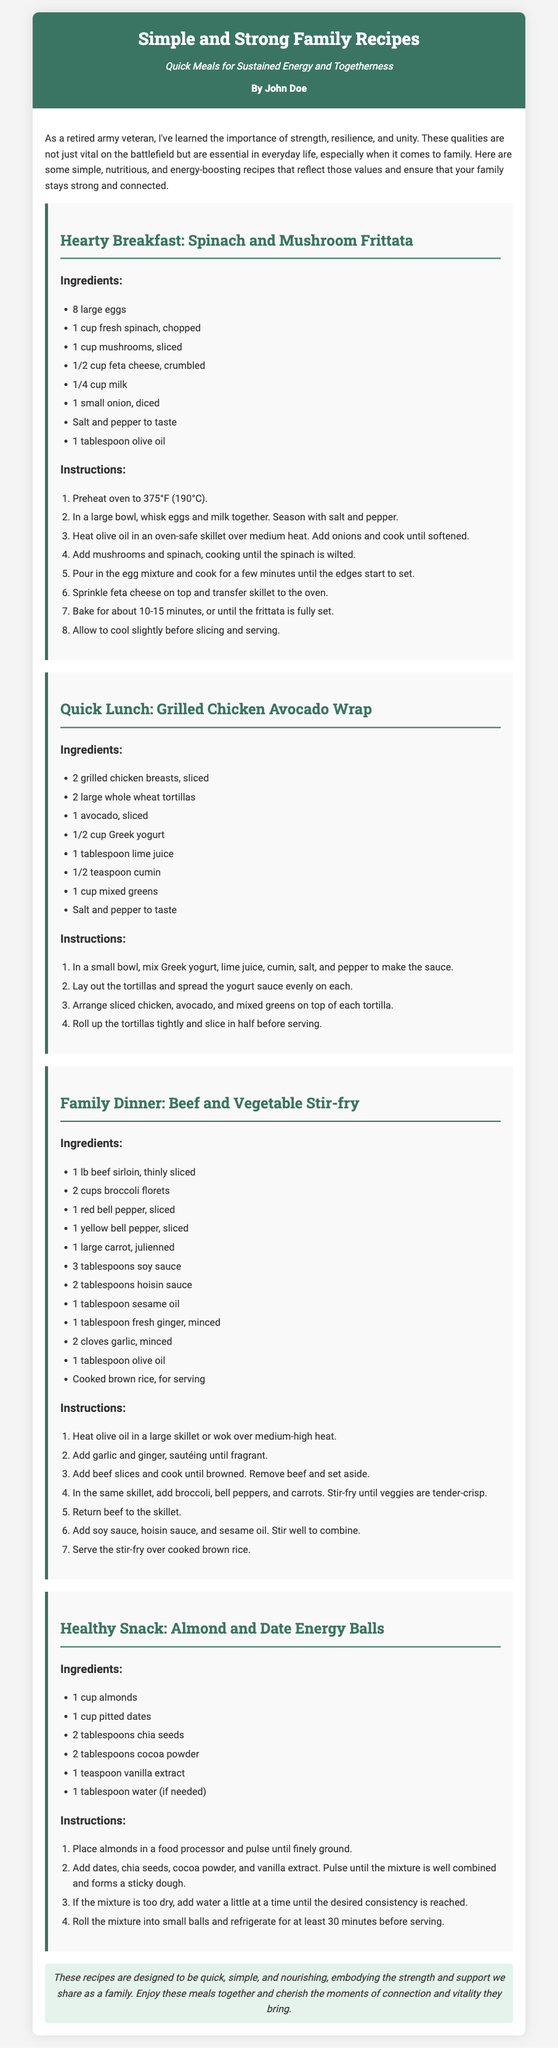What is the title of the document? The title is found at the top of the header section of the document.
Answer: Simple and Strong Family Recipes Who is the author of the recipes? The author is indicated in the header section.
Answer: John Doe What is the main ingredient in the Spinach and Mushroom Frittata? The recipe lists ingredients, and spinach is highlighted in the frittata section.
Answer: Spinach How many eggs are used in the frittata recipe? The ingredients for the frittata include a specific quantity of eggs.
Answer: 8 large eggs What is one of the sauces used in the Grilled Chicken Avocado Wrap? The wrap recipe includes a yogurt sauce made from specific ingredients.
Answer: Greek yogurt What is the cooking time for the Spinach and Mushroom Frittata? The instructions detail the baking time for the frittata.
Answer: 10-15 minutes Which recipe includes ginger as an ingredient? The Beef and Vegetable Stir-fry lists ginger in its ingredients.
Answer: Beef and Vegetable Stir-fry What is the purpose of these recipes, according to the introduction? The introduction explains the intent behind the recipes.
Answer: Strength and support What healthy snack is mentioned in the document? The snacks are listed under a specific category in the document.
Answer: Almond and Date Energy Balls 